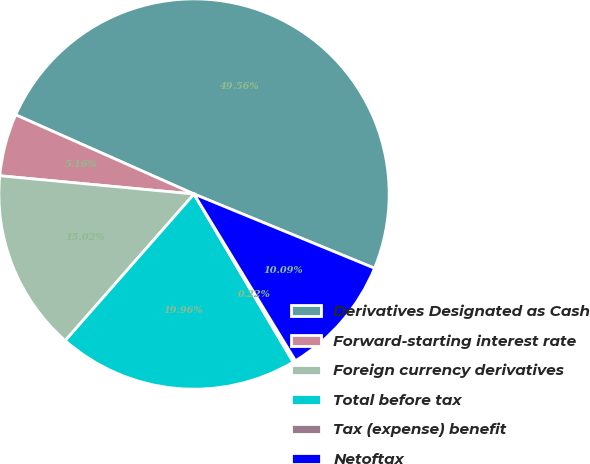Convert chart. <chart><loc_0><loc_0><loc_500><loc_500><pie_chart><fcel>Derivatives Designated as Cash<fcel>Forward-starting interest rate<fcel>Foreign currency derivatives<fcel>Total before tax<fcel>Tax (expense) benefit<fcel>Netoftax<nl><fcel>49.56%<fcel>5.16%<fcel>15.02%<fcel>19.96%<fcel>0.22%<fcel>10.09%<nl></chart> 